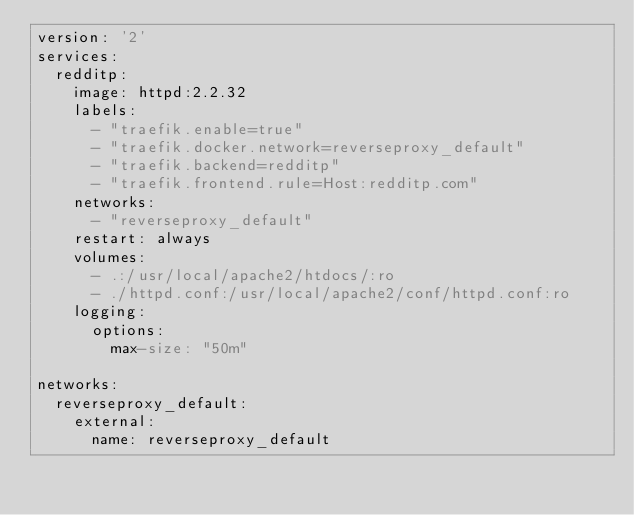<code> <loc_0><loc_0><loc_500><loc_500><_YAML_>version: '2'
services:
  redditp:
    image: httpd:2.2.32
    labels:
      - "traefik.enable=true"
      - "traefik.docker.network=reverseproxy_default"
      - "traefik.backend=redditp"
      - "traefik.frontend.rule=Host:redditp.com"
    networks:
      - "reverseproxy_default"
    restart: always
    volumes:
      - .:/usr/local/apache2/htdocs/:ro
      - ./httpd.conf:/usr/local/apache2/conf/httpd.conf:ro
    logging:
      options:
        max-size: "50m"

networks:
  reverseproxy_default:
    external:
      name: reverseproxy_default
</code> 